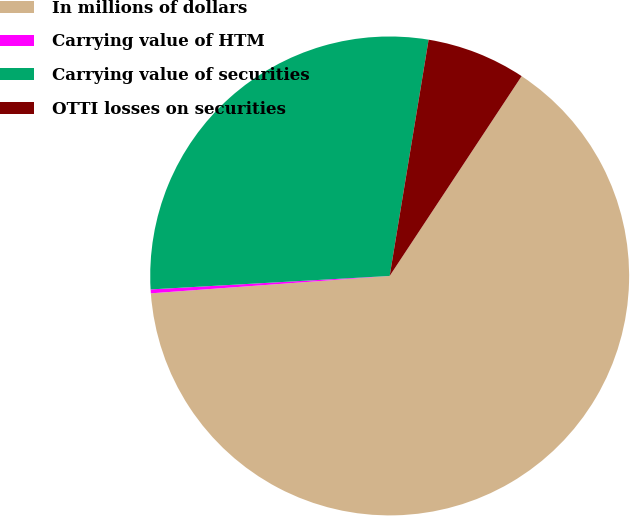<chart> <loc_0><loc_0><loc_500><loc_500><pie_chart><fcel>In millions of dollars<fcel>Carrying value of HTM<fcel>Carrying value of securities<fcel>OTTI losses on securities<nl><fcel>64.56%<fcel>0.26%<fcel>28.5%<fcel>6.69%<nl></chart> 